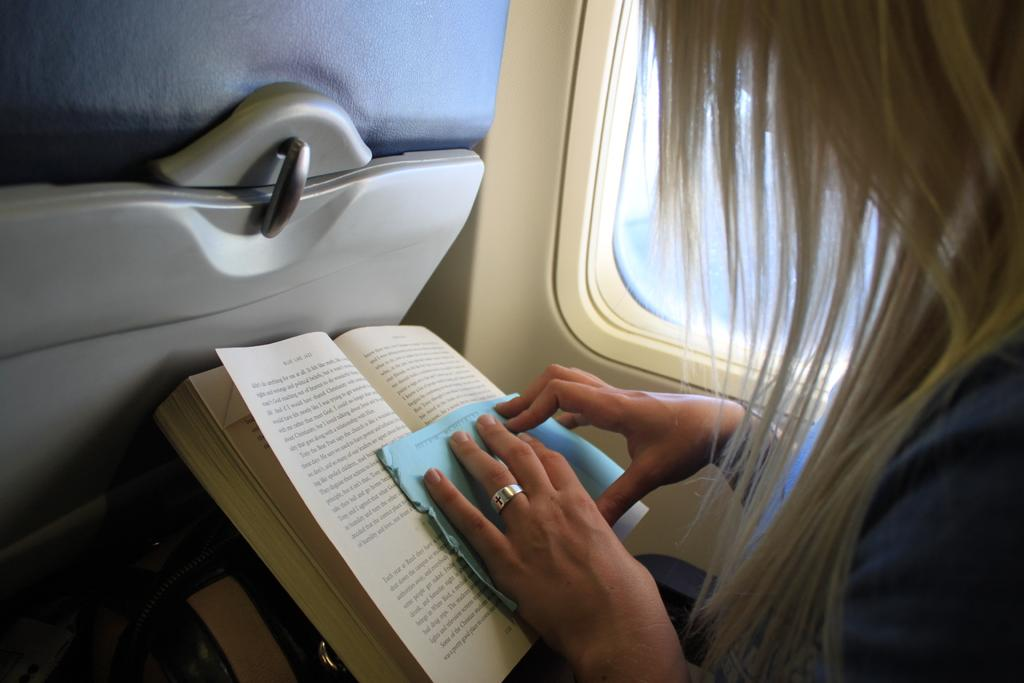Who is present in the image? There is a woman in the image. Where is the woman located? The woman is sitting in an airplane. What is the woman holding in the image? The woman is holding a paper. What else can be seen in front of the woman? There is a book in front of the woman. How does the woman support herself while skating in the image? There is no skating activity depicted in the image; the woman is sitting in an airplane. 